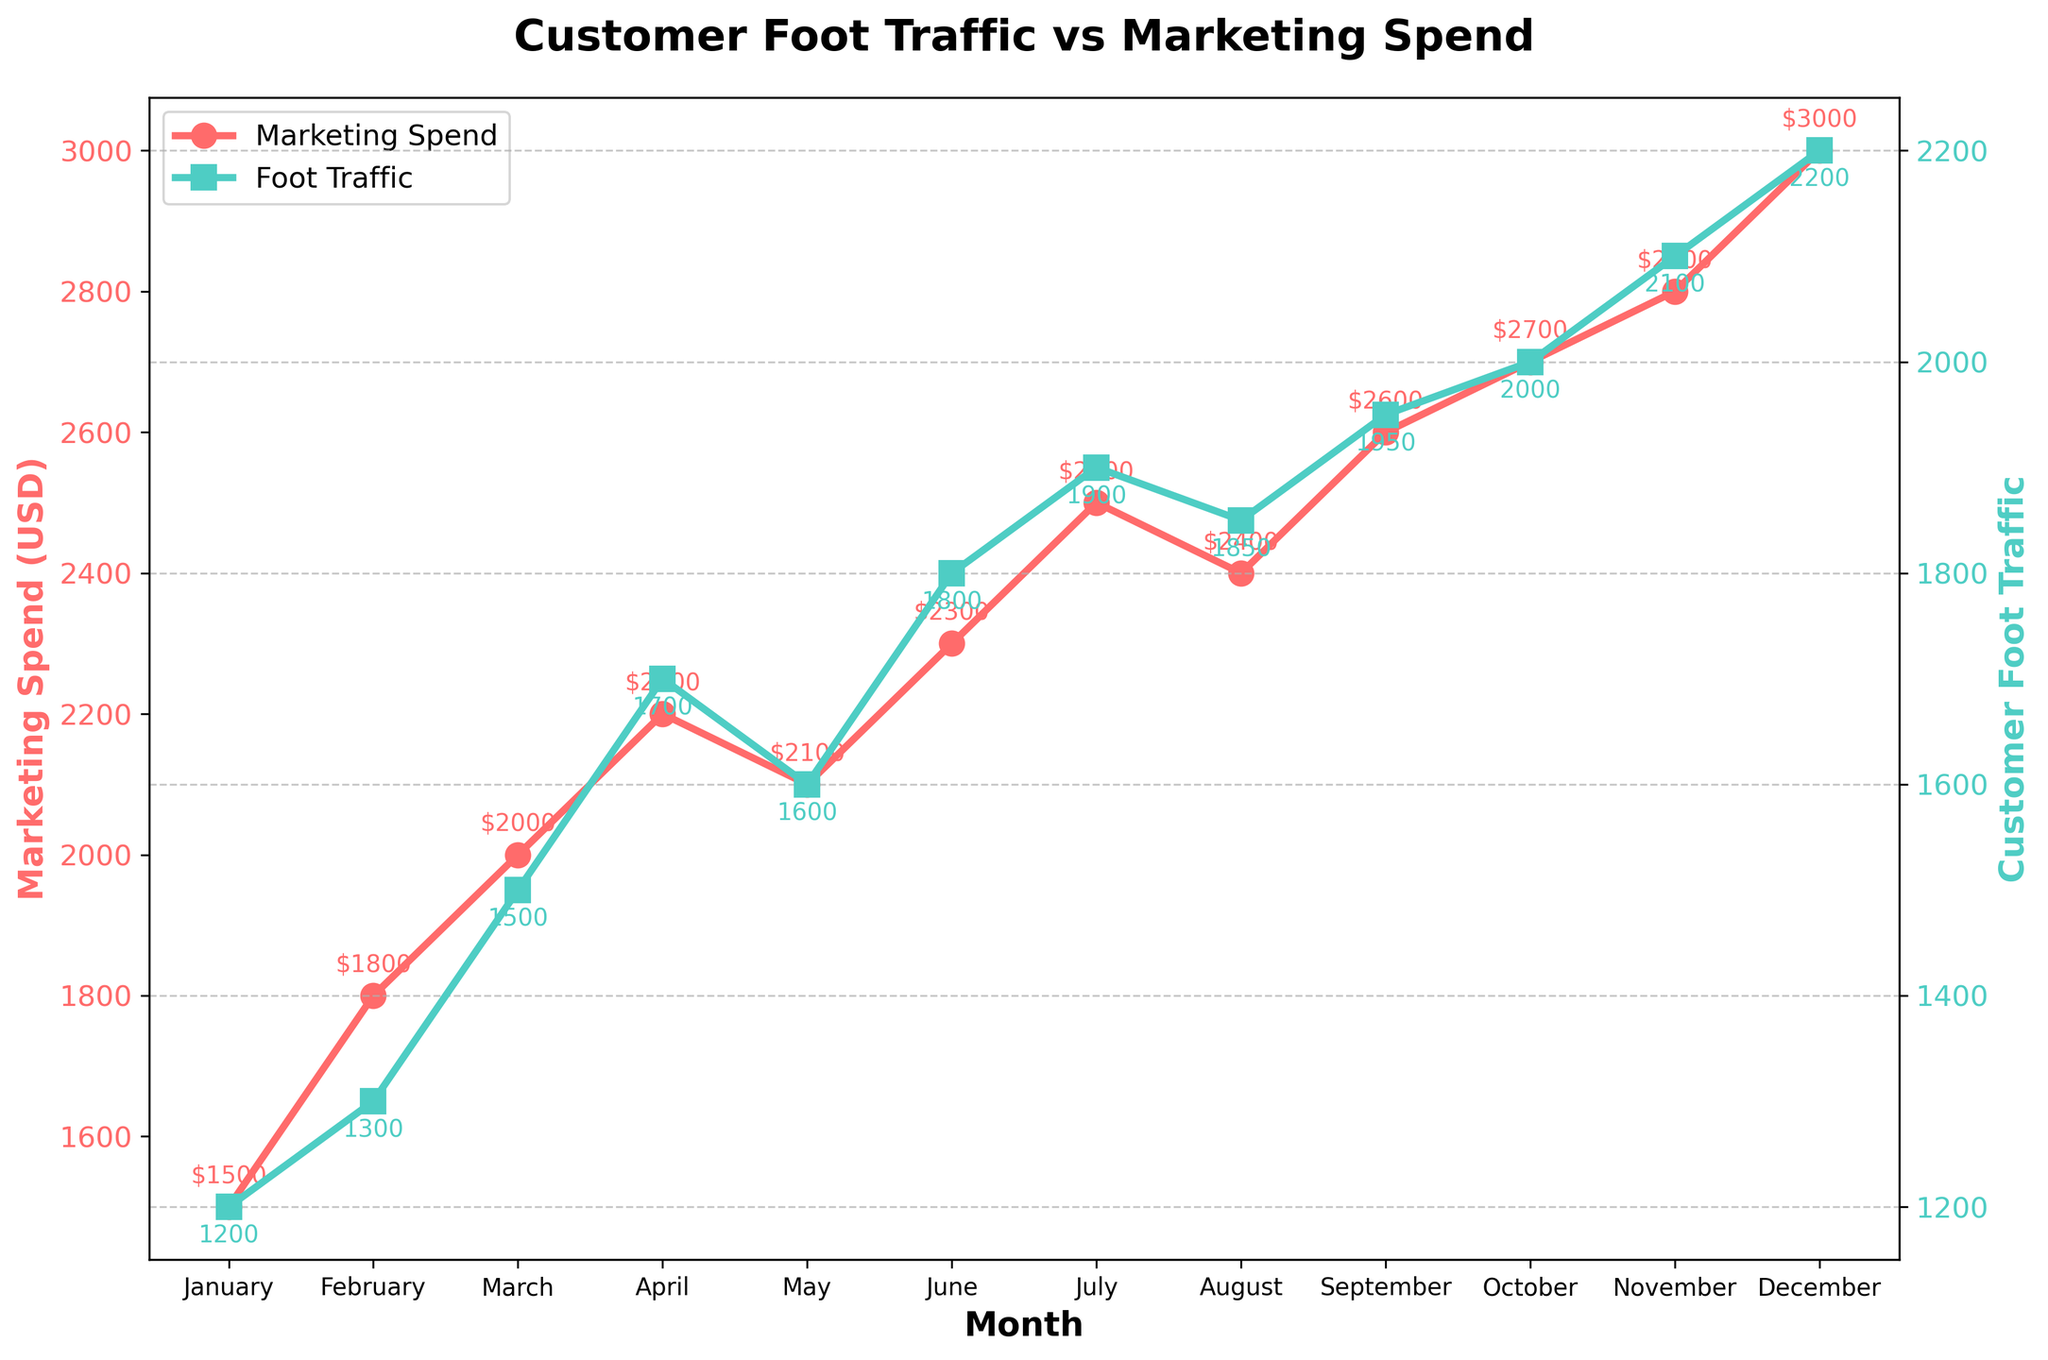What is the title of the figure? The title of the figure is generally located at the top and is the largest text in bold. Here, it reads "Customer Foot Traffic vs Marketing Spend."
Answer: Customer Foot Traffic vs Marketing Spend What is the marketing spend in June? To find the marketing spend for June, look for the corresponding point on the red line and locate the label or annotation that represents the spend amount. For June, it is $2300.
Answer: $2300 How does customer foot traffic change from September to October? To determine this, compare the values of customer foot traffic for September and October. In September, it is 1950, and in October, it is 2000, indicating an increase from September to October.
Answer: Increases Which month had the highest customer foot traffic? Locate the highest point on the green line (foot traffic) and identify the corresponding month. The highest value, 2200, occurs in December.
Answer: December What is the trend in marketing spend from January to December? Observing the red line, we notice a consistent upward trend from January to December, indicating increasing marketing spend.
Answer: Increasing What is the difference in customer foot traffic between July and August? Find the values for July and August, which are 1900 and 1850 respectively. Subtract August’s value from July’s: 1900 - 1850 = 50.
Answer: 50 By how much does marketing spend increase from January to December? Compare the marketing spend for January and December. January's spend is $1500, and December's is $3000. The difference is $3000 - $1500 = $1500.
Answer: $1500 Is there a correlation between marketing spend and customer foot traffic? By observing both the red and green lines, notice that as marketing spend increases, customer foot traffic generally increases as well, suggesting a positive correlation.
Answer: Yes Which month had the smallest increase in customer foot traffic compared to the previous month? Calculate the month-over-month increase for each month and identify the smallest. The smallest increase is from August (1850) to September (1950) with an increase of 100.
Answer: August to September What is the average marketing spend over the year? Sum up the marketing spends for all months and divide by the number of months (12). (1500 + 1800 + 2000 + 2200 + 2100 + 2300 + 2500 + 2400 + 2600 + 2700 + 2800 + 3000) / 12 = 2291.67.
Answer: 2291.67 